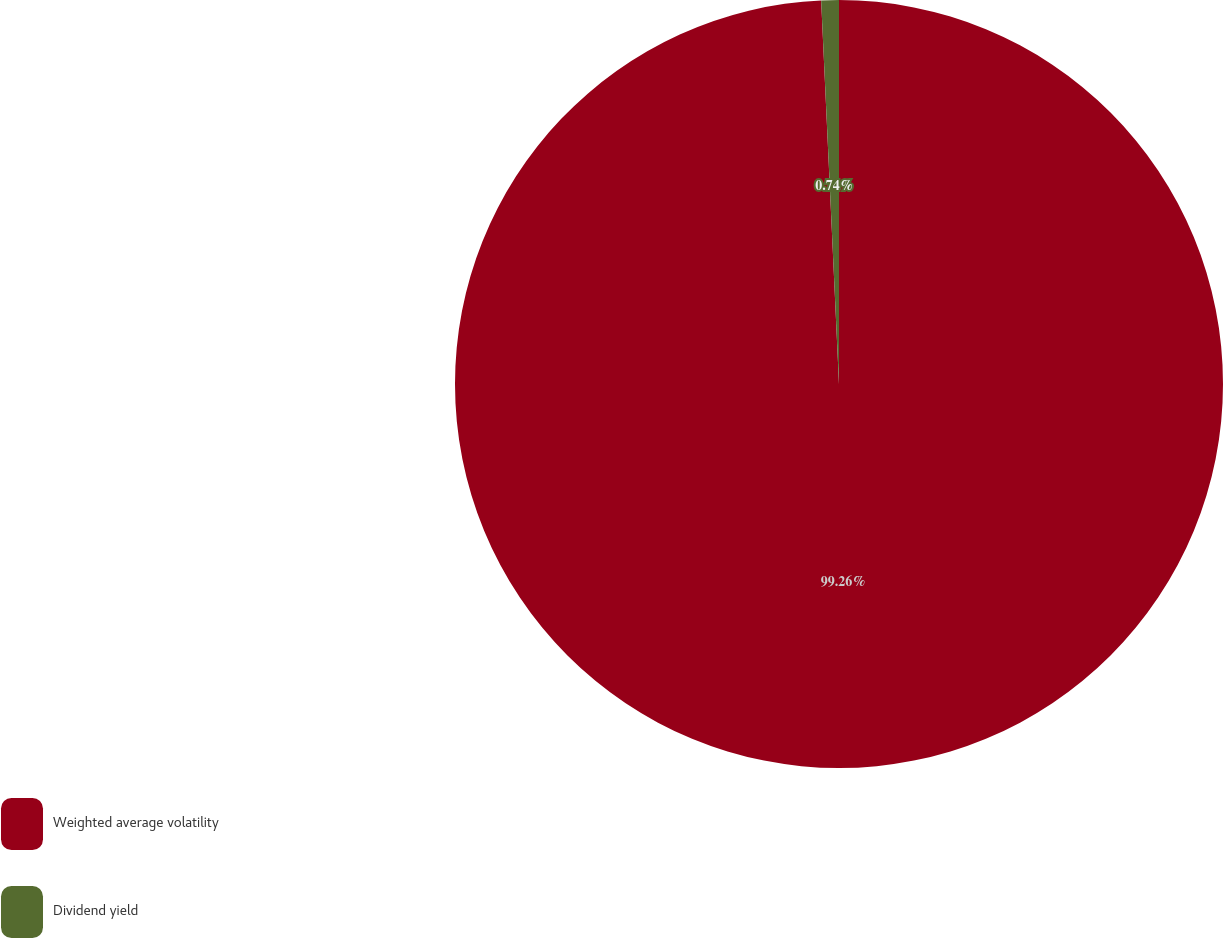<chart> <loc_0><loc_0><loc_500><loc_500><pie_chart><fcel>Weighted average volatility<fcel>Dividend yield<nl><fcel>99.26%<fcel>0.74%<nl></chart> 